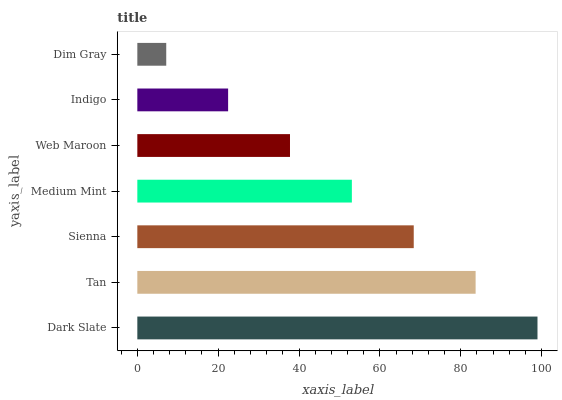Is Dim Gray the minimum?
Answer yes or no. Yes. Is Dark Slate the maximum?
Answer yes or no. Yes. Is Tan the minimum?
Answer yes or no. No. Is Tan the maximum?
Answer yes or no. No. Is Dark Slate greater than Tan?
Answer yes or no. Yes. Is Tan less than Dark Slate?
Answer yes or no. Yes. Is Tan greater than Dark Slate?
Answer yes or no. No. Is Dark Slate less than Tan?
Answer yes or no. No. Is Medium Mint the high median?
Answer yes or no. Yes. Is Medium Mint the low median?
Answer yes or no. Yes. Is Sienna the high median?
Answer yes or no. No. Is Indigo the low median?
Answer yes or no. No. 